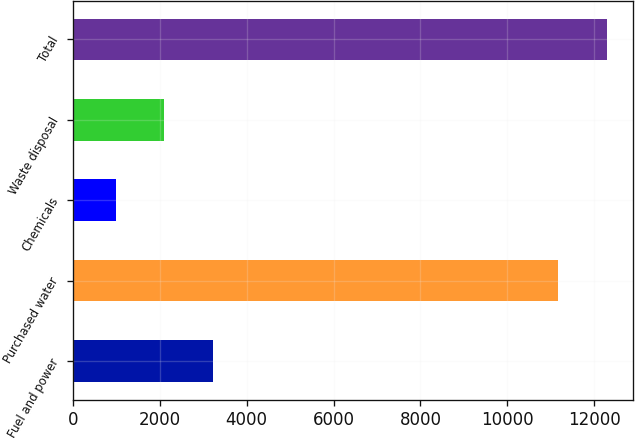<chart> <loc_0><loc_0><loc_500><loc_500><bar_chart><fcel>Fuel and power<fcel>Purchased water<fcel>Chemicals<fcel>Waste disposal<fcel>Total<nl><fcel>3226.4<fcel>11165<fcel>980<fcel>2103.2<fcel>12288.2<nl></chart> 